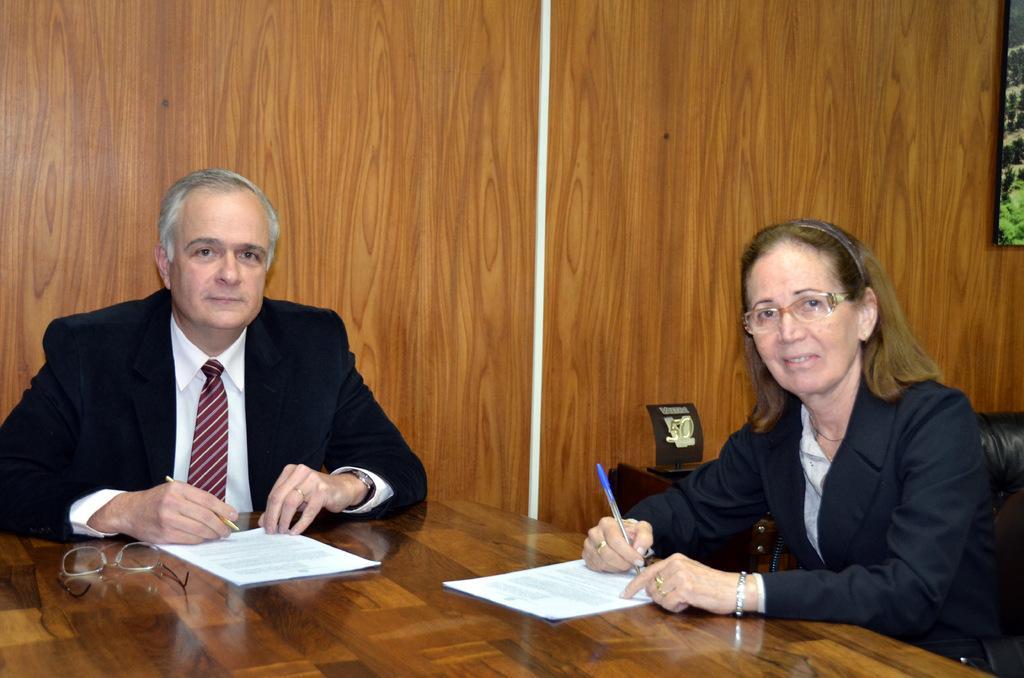Describe this image in one or two sentences. There are two people sitting one on the left side and another on the right side. There is a spec in the bottom left hand corner. 